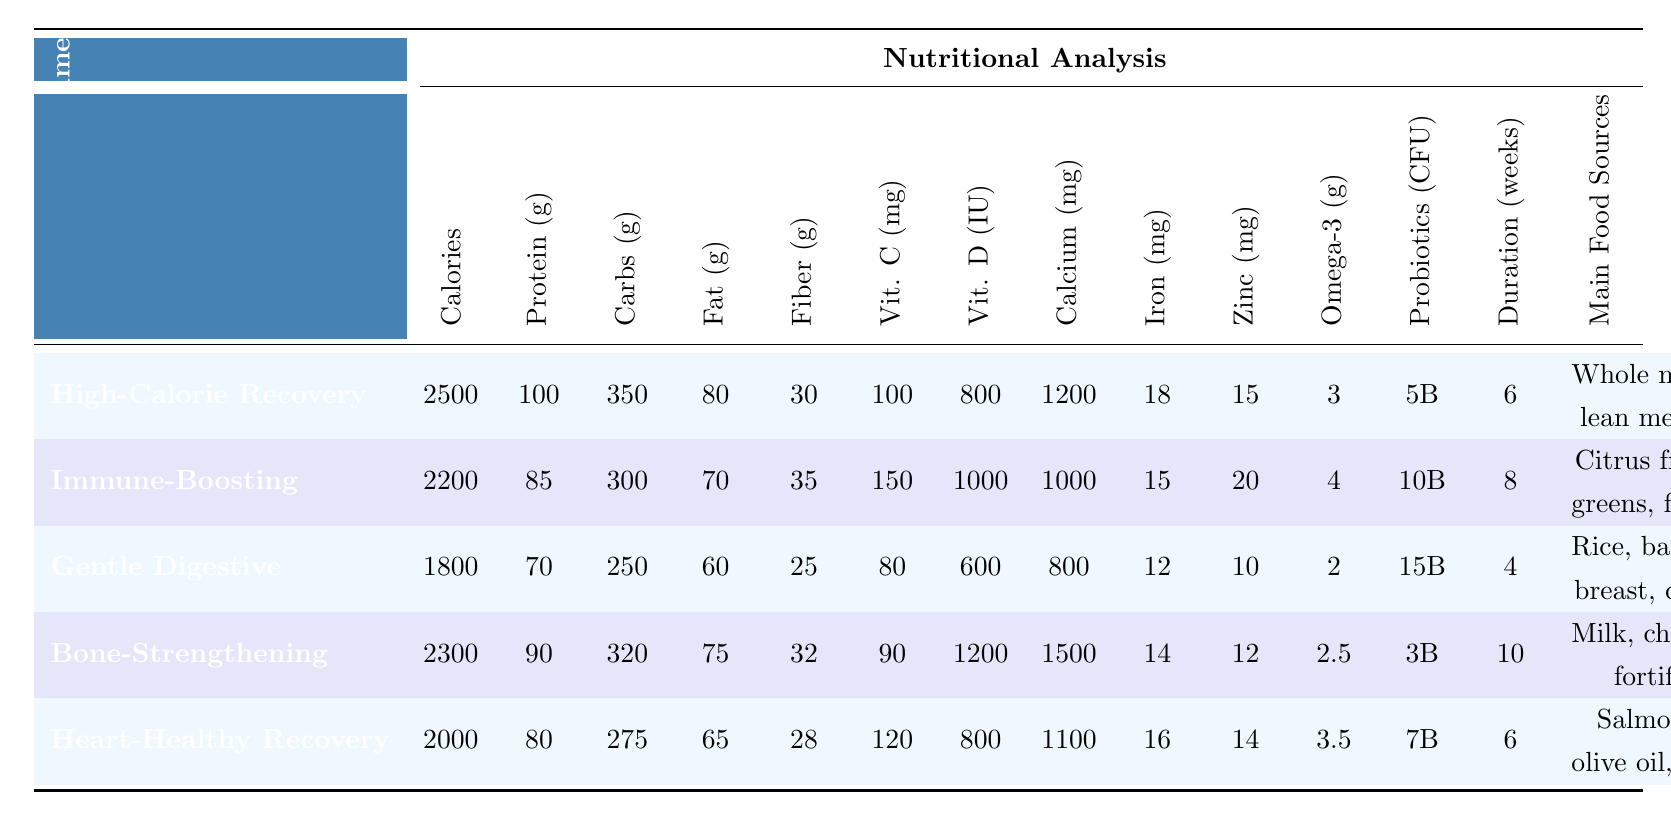What is the highest protein content among the diets? To find the diet with the highest protein content, we look at the Protein grams column. The values are 100, 85, 70, 90, and 80 grams. The highest value is 100 grams from the High-Calorie Recovery Diet.
Answer: 100 grams Which diet has the lowest carbohydrate content? The Carbohydrates grams column shows the values 350, 300, 250, 320, and 275 grams. The lowest value is 250 grams, which belongs to the Gentle Digestive Diet.
Answer: 250 grams How many calories does the Bone-Strengthening Diet provide? The Calories per Day column shows 2500, 2200, 1800, 2300, and 2000 calories. The value for the Bone-Strengthening Diet is 2300 calories.
Answer: 2300 calories Is the Iron content in the Immune-Boosting Diet higher than in the Heart-Healthy Recovery Diet? The Iron for the Immune-Boosting Diet is 15 mg, and for the Heart-Healthy Recovery Diet, it is 16 mg. Since 15 is less than 16, the Immune-Boosting Diet does not have higher Iron content.
Answer: No What is the total fat content in the High-Calorie Recovery and Bone-Strengthening diets? The Fat grams for the High-Calorie Recovery Diet is 80 grams and for the Bone-Strengthening Diet is 75 grams. Adding these together gives 80 + 75 = 155 grams.
Answer: 155 grams Which diet has the most Vitamin C, and how much does it contain? The Vitamin C mg column lists 100, 150, 80, 90, and 120 mg. The highest value is 150 mg from the Immune-Boosting Diet.
Answer: 150 mg What is the average Calcium content across all diets? The Calcium mg values are 1200, 1000, 800, 1500, and 1100 mg. Summing these gives 1200 + 1000 + 800 + 1500 + 1100 = 4600 mg. There are 5 diets, so the average is 4600/5 = 920 mg.
Answer: 920 mg How does the Omega-3 content of the Heart-Healthy Recovery Diet compare to the Gentle Digestive Diet? The Omega-3 grams for the Heart-Healthy Recovery Diet is 3.5 grams, while for the Gentle Digestive Diet, it is 2 grams. Since 3.5 is greater than 2, the Heart-Healthy Recovery Diet contains more Omega-3.
Answer: Yes Which diet is recommended for the longest duration? The Recommended Duration Weeks column shows values of 6, 8, 4, 10, and 6 weeks. The longest duration is 10 weeks for the Bone-Strengthening Diet.
Answer: 10 weeks What nutrient is highest in the Gentle Digestive Diet? Looking at the relevant columns, the protein content is 70 grams, carbohydrates is 250 grams, fat is 60 grams, fiber is 25 grams, and vitamin C is 80 mg. The highest nutrient value is Protein (70 grams) compared to others.
Answer: Protein (70 grams) 